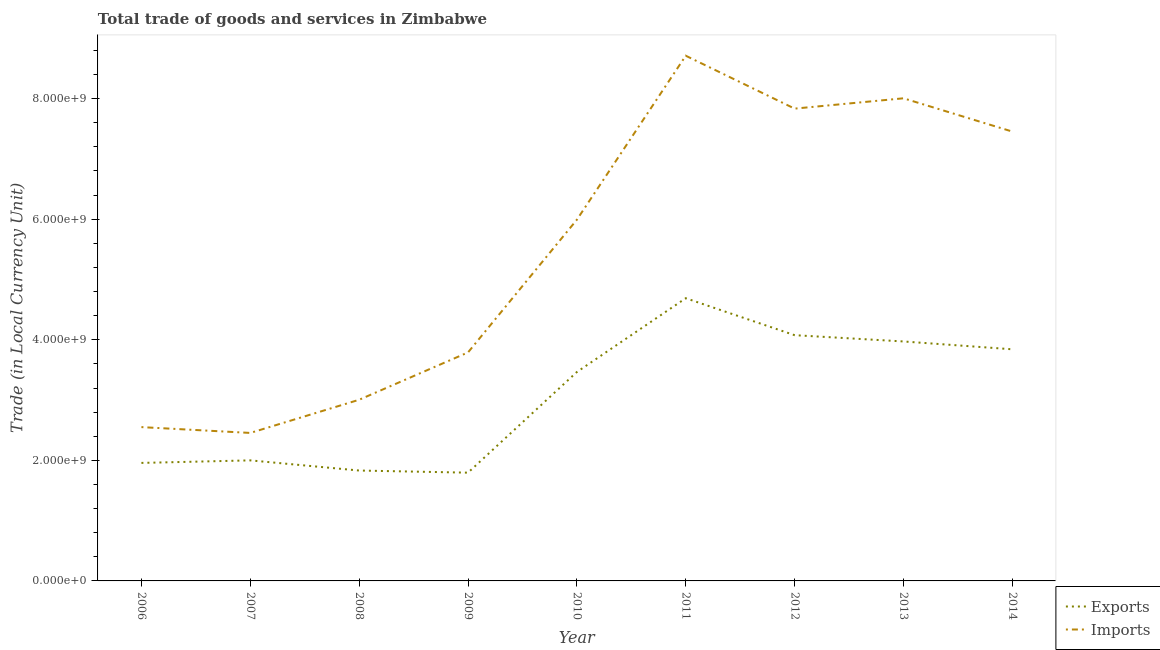Is the number of lines equal to the number of legend labels?
Offer a very short reply. Yes. What is the imports of goods and services in 2008?
Provide a short and direct response. 3.01e+09. Across all years, what is the maximum imports of goods and services?
Your response must be concise. 8.71e+09. Across all years, what is the minimum imports of goods and services?
Keep it short and to the point. 2.45e+09. What is the total imports of goods and services in the graph?
Ensure brevity in your answer.  4.98e+1. What is the difference between the export of goods and services in 2010 and that in 2013?
Your answer should be compact. -5.06e+08. What is the difference between the export of goods and services in 2006 and the imports of goods and services in 2010?
Offer a terse response. -4.03e+09. What is the average export of goods and services per year?
Provide a short and direct response. 3.07e+09. In the year 2014, what is the difference between the imports of goods and services and export of goods and services?
Your answer should be compact. 3.61e+09. In how many years, is the export of goods and services greater than 400000000 LCU?
Provide a succinct answer. 9. What is the ratio of the export of goods and services in 2009 to that in 2010?
Give a very brief answer. 0.52. Is the imports of goods and services in 2012 less than that in 2014?
Make the answer very short. No. What is the difference between the highest and the second highest export of goods and services?
Your answer should be very brief. 6.13e+08. What is the difference between the highest and the lowest imports of goods and services?
Make the answer very short. 6.26e+09. In how many years, is the imports of goods and services greater than the average imports of goods and services taken over all years?
Give a very brief answer. 5. Is the sum of the imports of goods and services in 2008 and 2009 greater than the maximum export of goods and services across all years?
Your answer should be very brief. Yes. Does the export of goods and services monotonically increase over the years?
Offer a very short reply. No. Is the export of goods and services strictly less than the imports of goods and services over the years?
Offer a terse response. Yes. How many lines are there?
Keep it short and to the point. 2. How many years are there in the graph?
Make the answer very short. 9. What is the difference between two consecutive major ticks on the Y-axis?
Your answer should be compact. 2.00e+09. Are the values on the major ticks of Y-axis written in scientific E-notation?
Offer a terse response. Yes. Where does the legend appear in the graph?
Make the answer very short. Bottom right. How are the legend labels stacked?
Your response must be concise. Vertical. What is the title of the graph?
Make the answer very short. Total trade of goods and services in Zimbabwe. What is the label or title of the Y-axis?
Provide a short and direct response. Trade (in Local Currency Unit). What is the Trade (in Local Currency Unit) of Exports in 2006?
Make the answer very short. 1.96e+09. What is the Trade (in Local Currency Unit) in Imports in 2006?
Offer a terse response. 2.55e+09. What is the Trade (in Local Currency Unit) of Exports in 2007?
Make the answer very short. 2.00e+09. What is the Trade (in Local Currency Unit) in Imports in 2007?
Your answer should be compact. 2.45e+09. What is the Trade (in Local Currency Unit) of Exports in 2008?
Your answer should be very brief. 1.83e+09. What is the Trade (in Local Currency Unit) in Imports in 2008?
Give a very brief answer. 3.01e+09. What is the Trade (in Local Currency Unit) in Exports in 2009?
Give a very brief answer. 1.80e+09. What is the Trade (in Local Currency Unit) of Imports in 2009?
Offer a very short reply. 3.79e+09. What is the Trade (in Local Currency Unit) in Exports in 2010?
Offer a very short reply. 3.47e+09. What is the Trade (in Local Currency Unit) in Imports in 2010?
Keep it short and to the point. 5.99e+09. What is the Trade (in Local Currency Unit) of Exports in 2011?
Your response must be concise. 4.69e+09. What is the Trade (in Local Currency Unit) of Imports in 2011?
Make the answer very short. 8.71e+09. What is the Trade (in Local Currency Unit) in Exports in 2012?
Your answer should be very brief. 4.08e+09. What is the Trade (in Local Currency Unit) in Imports in 2012?
Your answer should be compact. 7.83e+09. What is the Trade (in Local Currency Unit) in Exports in 2013?
Give a very brief answer. 3.97e+09. What is the Trade (in Local Currency Unit) of Imports in 2013?
Your answer should be compact. 8.01e+09. What is the Trade (in Local Currency Unit) of Exports in 2014?
Keep it short and to the point. 3.84e+09. What is the Trade (in Local Currency Unit) in Imports in 2014?
Keep it short and to the point. 7.45e+09. Across all years, what is the maximum Trade (in Local Currency Unit) of Exports?
Provide a succinct answer. 4.69e+09. Across all years, what is the maximum Trade (in Local Currency Unit) of Imports?
Make the answer very short. 8.71e+09. Across all years, what is the minimum Trade (in Local Currency Unit) of Exports?
Give a very brief answer. 1.80e+09. Across all years, what is the minimum Trade (in Local Currency Unit) of Imports?
Make the answer very short. 2.45e+09. What is the total Trade (in Local Currency Unit) in Exports in the graph?
Keep it short and to the point. 2.76e+1. What is the total Trade (in Local Currency Unit) of Imports in the graph?
Provide a short and direct response. 4.98e+1. What is the difference between the Trade (in Local Currency Unit) in Exports in 2006 and that in 2007?
Your response must be concise. -4.22e+07. What is the difference between the Trade (in Local Currency Unit) of Imports in 2006 and that in 2007?
Ensure brevity in your answer.  9.64e+07. What is the difference between the Trade (in Local Currency Unit) in Exports in 2006 and that in 2008?
Offer a terse response. 1.26e+08. What is the difference between the Trade (in Local Currency Unit) of Imports in 2006 and that in 2008?
Your response must be concise. -4.54e+08. What is the difference between the Trade (in Local Currency Unit) in Exports in 2006 and that in 2009?
Provide a succinct answer. 1.62e+08. What is the difference between the Trade (in Local Currency Unit) of Imports in 2006 and that in 2009?
Provide a succinct answer. -1.24e+09. What is the difference between the Trade (in Local Currency Unit) in Exports in 2006 and that in 2010?
Offer a terse response. -1.51e+09. What is the difference between the Trade (in Local Currency Unit) in Imports in 2006 and that in 2010?
Provide a short and direct response. -3.44e+09. What is the difference between the Trade (in Local Currency Unit) in Exports in 2006 and that in 2011?
Provide a succinct answer. -2.73e+09. What is the difference between the Trade (in Local Currency Unit) in Imports in 2006 and that in 2011?
Ensure brevity in your answer.  -6.16e+09. What is the difference between the Trade (in Local Currency Unit) in Exports in 2006 and that in 2012?
Give a very brief answer. -2.12e+09. What is the difference between the Trade (in Local Currency Unit) in Imports in 2006 and that in 2012?
Provide a short and direct response. -5.28e+09. What is the difference between the Trade (in Local Currency Unit) in Exports in 2006 and that in 2013?
Keep it short and to the point. -2.01e+09. What is the difference between the Trade (in Local Currency Unit) of Imports in 2006 and that in 2013?
Your response must be concise. -5.45e+09. What is the difference between the Trade (in Local Currency Unit) of Exports in 2006 and that in 2014?
Keep it short and to the point. -1.88e+09. What is the difference between the Trade (in Local Currency Unit) in Imports in 2006 and that in 2014?
Offer a terse response. -4.90e+09. What is the difference between the Trade (in Local Currency Unit) of Exports in 2007 and that in 2008?
Provide a short and direct response. 1.69e+08. What is the difference between the Trade (in Local Currency Unit) of Imports in 2007 and that in 2008?
Make the answer very short. -5.50e+08. What is the difference between the Trade (in Local Currency Unit) in Exports in 2007 and that in 2009?
Make the answer very short. 2.04e+08. What is the difference between the Trade (in Local Currency Unit) in Imports in 2007 and that in 2009?
Your answer should be compact. -1.34e+09. What is the difference between the Trade (in Local Currency Unit) of Exports in 2007 and that in 2010?
Offer a very short reply. -1.47e+09. What is the difference between the Trade (in Local Currency Unit) in Imports in 2007 and that in 2010?
Your response must be concise. -3.54e+09. What is the difference between the Trade (in Local Currency Unit) of Exports in 2007 and that in 2011?
Provide a succinct answer. -2.69e+09. What is the difference between the Trade (in Local Currency Unit) of Imports in 2007 and that in 2011?
Give a very brief answer. -6.26e+09. What is the difference between the Trade (in Local Currency Unit) in Exports in 2007 and that in 2012?
Your response must be concise. -2.08e+09. What is the difference between the Trade (in Local Currency Unit) of Imports in 2007 and that in 2012?
Offer a very short reply. -5.38e+09. What is the difference between the Trade (in Local Currency Unit) in Exports in 2007 and that in 2013?
Your answer should be compact. -1.97e+09. What is the difference between the Trade (in Local Currency Unit) in Imports in 2007 and that in 2013?
Keep it short and to the point. -5.55e+09. What is the difference between the Trade (in Local Currency Unit) in Exports in 2007 and that in 2014?
Your answer should be compact. -1.84e+09. What is the difference between the Trade (in Local Currency Unit) in Imports in 2007 and that in 2014?
Ensure brevity in your answer.  -5.00e+09. What is the difference between the Trade (in Local Currency Unit) in Exports in 2008 and that in 2009?
Your answer should be very brief. 3.54e+07. What is the difference between the Trade (in Local Currency Unit) in Imports in 2008 and that in 2009?
Your answer should be compact. -7.85e+08. What is the difference between the Trade (in Local Currency Unit) of Exports in 2008 and that in 2010?
Offer a very short reply. -1.63e+09. What is the difference between the Trade (in Local Currency Unit) of Imports in 2008 and that in 2010?
Offer a very short reply. -2.99e+09. What is the difference between the Trade (in Local Currency Unit) in Exports in 2008 and that in 2011?
Offer a very short reply. -2.86e+09. What is the difference between the Trade (in Local Currency Unit) of Imports in 2008 and that in 2011?
Make the answer very short. -5.71e+09. What is the difference between the Trade (in Local Currency Unit) of Exports in 2008 and that in 2012?
Give a very brief answer. -2.25e+09. What is the difference between the Trade (in Local Currency Unit) of Imports in 2008 and that in 2012?
Give a very brief answer. -4.83e+09. What is the difference between the Trade (in Local Currency Unit) in Exports in 2008 and that in 2013?
Keep it short and to the point. -2.14e+09. What is the difference between the Trade (in Local Currency Unit) in Imports in 2008 and that in 2013?
Make the answer very short. -5.00e+09. What is the difference between the Trade (in Local Currency Unit) of Exports in 2008 and that in 2014?
Provide a succinct answer. -2.01e+09. What is the difference between the Trade (in Local Currency Unit) in Imports in 2008 and that in 2014?
Offer a terse response. -4.45e+09. What is the difference between the Trade (in Local Currency Unit) of Exports in 2009 and that in 2010?
Make the answer very short. -1.67e+09. What is the difference between the Trade (in Local Currency Unit) in Imports in 2009 and that in 2010?
Your response must be concise. -2.20e+09. What is the difference between the Trade (in Local Currency Unit) in Exports in 2009 and that in 2011?
Make the answer very short. -2.89e+09. What is the difference between the Trade (in Local Currency Unit) in Imports in 2009 and that in 2011?
Offer a very short reply. -4.92e+09. What is the difference between the Trade (in Local Currency Unit) of Exports in 2009 and that in 2012?
Your answer should be very brief. -2.28e+09. What is the difference between the Trade (in Local Currency Unit) of Imports in 2009 and that in 2012?
Your answer should be compact. -4.04e+09. What is the difference between the Trade (in Local Currency Unit) in Exports in 2009 and that in 2013?
Offer a terse response. -2.18e+09. What is the difference between the Trade (in Local Currency Unit) of Imports in 2009 and that in 2013?
Ensure brevity in your answer.  -4.22e+09. What is the difference between the Trade (in Local Currency Unit) of Exports in 2009 and that in 2014?
Offer a very short reply. -2.05e+09. What is the difference between the Trade (in Local Currency Unit) of Imports in 2009 and that in 2014?
Give a very brief answer. -3.66e+09. What is the difference between the Trade (in Local Currency Unit) in Exports in 2010 and that in 2011?
Your answer should be compact. -1.22e+09. What is the difference between the Trade (in Local Currency Unit) of Imports in 2010 and that in 2011?
Provide a succinct answer. -2.72e+09. What is the difference between the Trade (in Local Currency Unit) in Exports in 2010 and that in 2012?
Your response must be concise. -6.11e+08. What is the difference between the Trade (in Local Currency Unit) of Imports in 2010 and that in 2012?
Your response must be concise. -1.84e+09. What is the difference between the Trade (in Local Currency Unit) of Exports in 2010 and that in 2013?
Your response must be concise. -5.06e+08. What is the difference between the Trade (in Local Currency Unit) of Imports in 2010 and that in 2013?
Make the answer very short. -2.01e+09. What is the difference between the Trade (in Local Currency Unit) of Exports in 2010 and that in 2014?
Make the answer very short. -3.76e+08. What is the difference between the Trade (in Local Currency Unit) in Imports in 2010 and that in 2014?
Offer a very short reply. -1.46e+09. What is the difference between the Trade (in Local Currency Unit) in Exports in 2011 and that in 2012?
Your answer should be very brief. 6.13e+08. What is the difference between the Trade (in Local Currency Unit) in Imports in 2011 and that in 2012?
Your answer should be very brief. 8.77e+08. What is the difference between the Trade (in Local Currency Unit) of Exports in 2011 and that in 2013?
Provide a short and direct response. 7.17e+08. What is the difference between the Trade (in Local Currency Unit) in Imports in 2011 and that in 2013?
Your answer should be very brief. 7.06e+08. What is the difference between the Trade (in Local Currency Unit) in Exports in 2011 and that in 2014?
Your response must be concise. 8.47e+08. What is the difference between the Trade (in Local Currency Unit) of Imports in 2011 and that in 2014?
Your response must be concise. 1.26e+09. What is the difference between the Trade (in Local Currency Unit) of Exports in 2012 and that in 2013?
Your answer should be very brief. 1.04e+08. What is the difference between the Trade (in Local Currency Unit) in Imports in 2012 and that in 2013?
Give a very brief answer. -1.71e+08. What is the difference between the Trade (in Local Currency Unit) of Exports in 2012 and that in 2014?
Offer a terse response. 2.34e+08. What is the difference between the Trade (in Local Currency Unit) of Imports in 2012 and that in 2014?
Provide a short and direct response. 3.81e+08. What is the difference between the Trade (in Local Currency Unit) in Exports in 2013 and that in 2014?
Make the answer very short. 1.30e+08. What is the difference between the Trade (in Local Currency Unit) of Imports in 2013 and that in 2014?
Keep it short and to the point. 5.52e+08. What is the difference between the Trade (in Local Currency Unit) of Exports in 2006 and the Trade (in Local Currency Unit) of Imports in 2007?
Ensure brevity in your answer.  -4.97e+08. What is the difference between the Trade (in Local Currency Unit) in Exports in 2006 and the Trade (in Local Currency Unit) in Imports in 2008?
Your answer should be very brief. -1.05e+09. What is the difference between the Trade (in Local Currency Unit) in Exports in 2006 and the Trade (in Local Currency Unit) in Imports in 2009?
Your answer should be very brief. -1.83e+09. What is the difference between the Trade (in Local Currency Unit) of Exports in 2006 and the Trade (in Local Currency Unit) of Imports in 2010?
Offer a very short reply. -4.03e+09. What is the difference between the Trade (in Local Currency Unit) of Exports in 2006 and the Trade (in Local Currency Unit) of Imports in 2011?
Keep it short and to the point. -6.75e+09. What is the difference between the Trade (in Local Currency Unit) of Exports in 2006 and the Trade (in Local Currency Unit) of Imports in 2012?
Keep it short and to the point. -5.88e+09. What is the difference between the Trade (in Local Currency Unit) in Exports in 2006 and the Trade (in Local Currency Unit) in Imports in 2013?
Offer a terse response. -6.05e+09. What is the difference between the Trade (in Local Currency Unit) in Exports in 2006 and the Trade (in Local Currency Unit) in Imports in 2014?
Provide a short and direct response. -5.50e+09. What is the difference between the Trade (in Local Currency Unit) in Exports in 2007 and the Trade (in Local Currency Unit) in Imports in 2008?
Your answer should be compact. -1.01e+09. What is the difference between the Trade (in Local Currency Unit) in Exports in 2007 and the Trade (in Local Currency Unit) in Imports in 2009?
Give a very brief answer. -1.79e+09. What is the difference between the Trade (in Local Currency Unit) in Exports in 2007 and the Trade (in Local Currency Unit) in Imports in 2010?
Give a very brief answer. -3.99e+09. What is the difference between the Trade (in Local Currency Unit) in Exports in 2007 and the Trade (in Local Currency Unit) in Imports in 2011?
Your answer should be compact. -6.71e+09. What is the difference between the Trade (in Local Currency Unit) of Exports in 2007 and the Trade (in Local Currency Unit) of Imports in 2012?
Provide a short and direct response. -5.83e+09. What is the difference between the Trade (in Local Currency Unit) in Exports in 2007 and the Trade (in Local Currency Unit) in Imports in 2013?
Offer a very short reply. -6.01e+09. What is the difference between the Trade (in Local Currency Unit) in Exports in 2007 and the Trade (in Local Currency Unit) in Imports in 2014?
Give a very brief answer. -5.45e+09. What is the difference between the Trade (in Local Currency Unit) of Exports in 2008 and the Trade (in Local Currency Unit) of Imports in 2009?
Provide a succinct answer. -1.96e+09. What is the difference between the Trade (in Local Currency Unit) in Exports in 2008 and the Trade (in Local Currency Unit) in Imports in 2010?
Provide a short and direct response. -4.16e+09. What is the difference between the Trade (in Local Currency Unit) in Exports in 2008 and the Trade (in Local Currency Unit) in Imports in 2011?
Your response must be concise. -6.88e+09. What is the difference between the Trade (in Local Currency Unit) of Exports in 2008 and the Trade (in Local Currency Unit) of Imports in 2012?
Your answer should be very brief. -6.00e+09. What is the difference between the Trade (in Local Currency Unit) of Exports in 2008 and the Trade (in Local Currency Unit) of Imports in 2013?
Your answer should be very brief. -6.17e+09. What is the difference between the Trade (in Local Currency Unit) in Exports in 2008 and the Trade (in Local Currency Unit) in Imports in 2014?
Your answer should be very brief. -5.62e+09. What is the difference between the Trade (in Local Currency Unit) in Exports in 2009 and the Trade (in Local Currency Unit) in Imports in 2010?
Provide a short and direct response. -4.20e+09. What is the difference between the Trade (in Local Currency Unit) in Exports in 2009 and the Trade (in Local Currency Unit) in Imports in 2011?
Your response must be concise. -6.92e+09. What is the difference between the Trade (in Local Currency Unit) of Exports in 2009 and the Trade (in Local Currency Unit) of Imports in 2012?
Your answer should be compact. -6.04e+09. What is the difference between the Trade (in Local Currency Unit) in Exports in 2009 and the Trade (in Local Currency Unit) in Imports in 2013?
Your response must be concise. -6.21e+09. What is the difference between the Trade (in Local Currency Unit) in Exports in 2009 and the Trade (in Local Currency Unit) in Imports in 2014?
Provide a short and direct response. -5.66e+09. What is the difference between the Trade (in Local Currency Unit) in Exports in 2010 and the Trade (in Local Currency Unit) in Imports in 2011?
Your answer should be compact. -5.25e+09. What is the difference between the Trade (in Local Currency Unit) in Exports in 2010 and the Trade (in Local Currency Unit) in Imports in 2012?
Provide a short and direct response. -4.37e+09. What is the difference between the Trade (in Local Currency Unit) of Exports in 2010 and the Trade (in Local Currency Unit) of Imports in 2013?
Your response must be concise. -4.54e+09. What is the difference between the Trade (in Local Currency Unit) in Exports in 2010 and the Trade (in Local Currency Unit) in Imports in 2014?
Offer a terse response. -3.99e+09. What is the difference between the Trade (in Local Currency Unit) of Exports in 2011 and the Trade (in Local Currency Unit) of Imports in 2012?
Offer a very short reply. -3.14e+09. What is the difference between the Trade (in Local Currency Unit) in Exports in 2011 and the Trade (in Local Currency Unit) in Imports in 2013?
Your response must be concise. -3.32e+09. What is the difference between the Trade (in Local Currency Unit) in Exports in 2011 and the Trade (in Local Currency Unit) in Imports in 2014?
Make the answer very short. -2.76e+09. What is the difference between the Trade (in Local Currency Unit) in Exports in 2012 and the Trade (in Local Currency Unit) in Imports in 2013?
Offer a very short reply. -3.93e+09. What is the difference between the Trade (in Local Currency Unit) in Exports in 2012 and the Trade (in Local Currency Unit) in Imports in 2014?
Keep it short and to the point. -3.38e+09. What is the difference between the Trade (in Local Currency Unit) of Exports in 2013 and the Trade (in Local Currency Unit) of Imports in 2014?
Keep it short and to the point. -3.48e+09. What is the average Trade (in Local Currency Unit) of Exports per year?
Offer a very short reply. 3.07e+09. What is the average Trade (in Local Currency Unit) of Imports per year?
Your response must be concise. 5.53e+09. In the year 2006, what is the difference between the Trade (in Local Currency Unit) of Exports and Trade (in Local Currency Unit) of Imports?
Offer a very short reply. -5.94e+08. In the year 2007, what is the difference between the Trade (in Local Currency Unit) of Exports and Trade (in Local Currency Unit) of Imports?
Your answer should be very brief. -4.55e+08. In the year 2008, what is the difference between the Trade (in Local Currency Unit) in Exports and Trade (in Local Currency Unit) in Imports?
Provide a succinct answer. -1.17e+09. In the year 2009, what is the difference between the Trade (in Local Currency Unit) of Exports and Trade (in Local Currency Unit) of Imports?
Provide a succinct answer. -1.99e+09. In the year 2010, what is the difference between the Trade (in Local Currency Unit) in Exports and Trade (in Local Currency Unit) in Imports?
Your answer should be compact. -2.53e+09. In the year 2011, what is the difference between the Trade (in Local Currency Unit) of Exports and Trade (in Local Currency Unit) of Imports?
Make the answer very short. -4.02e+09. In the year 2012, what is the difference between the Trade (in Local Currency Unit) in Exports and Trade (in Local Currency Unit) in Imports?
Offer a terse response. -3.76e+09. In the year 2013, what is the difference between the Trade (in Local Currency Unit) in Exports and Trade (in Local Currency Unit) in Imports?
Ensure brevity in your answer.  -4.03e+09. In the year 2014, what is the difference between the Trade (in Local Currency Unit) of Exports and Trade (in Local Currency Unit) of Imports?
Your answer should be very brief. -3.61e+09. What is the ratio of the Trade (in Local Currency Unit) in Exports in 2006 to that in 2007?
Offer a very short reply. 0.98. What is the ratio of the Trade (in Local Currency Unit) of Imports in 2006 to that in 2007?
Provide a succinct answer. 1.04. What is the ratio of the Trade (in Local Currency Unit) in Exports in 2006 to that in 2008?
Offer a terse response. 1.07. What is the ratio of the Trade (in Local Currency Unit) in Imports in 2006 to that in 2008?
Ensure brevity in your answer.  0.85. What is the ratio of the Trade (in Local Currency Unit) in Exports in 2006 to that in 2009?
Your answer should be compact. 1.09. What is the ratio of the Trade (in Local Currency Unit) of Imports in 2006 to that in 2009?
Your response must be concise. 0.67. What is the ratio of the Trade (in Local Currency Unit) of Exports in 2006 to that in 2010?
Provide a short and direct response. 0.56. What is the ratio of the Trade (in Local Currency Unit) of Imports in 2006 to that in 2010?
Keep it short and to the point. 0.43. What is the ratio of the Trade (in Local Currency Unit) of Exports in 2006 to that in 2011?
Offer a terse response. 0.42. What is the ratio of the Trade (in Local Currency Unit) of Imports in 2006 to that in 2011?
Provide a short and direct response. 0.29. What is the ratio of the Trade (in Local Currency Unit) in Exports in 2006 to that in 2012?
Your answer should be compact. 0.48. What is the ratio of the Trade (in Local Currency Unit) in Imports in 2006 to that in 2012?
Give a very brief answer. 0.33. What is the ratio of the Trade (in Local Currency Unit) of Exports in 2006 to that in 2013?
Offer a terse response. 0.49. What is the ratio of the Trade (in Local Currency Unit) of Imports in 2006 to that in 2013?
Your answer should be compact. 0.32. What is the ratio of the Trade (in Local Currency Unit) of Exports in 2006 to that in 2014?
Provide a short and direct response. 0.51. What is the ratio of the Trade (in Local Currency Unit) of Imports in 2006 to that in 2014?
Your answer should be very brief. 0.34. What is the ratio of the Trade (in Local Currency Unit) of Exports in 2007 to that in 2008?
Offer a very short reply. 1.09. What is the ratio of the Trade (in Local Currency Unit) in Imports in 2007 to that in 2008?
Ensure brevity in your answer.  0.82. What is the ratio of the Trade (in Local Currency Unit) of Exports in 2007 to that in 2009?
Your answer should be very brief. 1.11. What is the ratio of the Trade (in Local Currency Unit) in Imports in 2007 to that in 2009?
Keep it short and to the point. 0.65. What is the ratio of the Trade (in Local Currency Unit) of Exports in 2007 to that in 2010?
Give a very brief answer. 0.58. What is the ratio of the Trade (in Local Currency Unit) in Imports in 2007 to that in 2010?
Your response must be concise. 0.41. What is the ratio of the Trade (in Local Currency Unit) in Exports in 2007 to that in 2011?
Provide a succinct answer. 0.43. What is the ratio of the Trade (in Local Currency Unit) of Imports in 2007 to that in 2011?
Give a very brief answer. 0.28. What is the ratio of the Trade (in Local Currency Unit) in Exports in 2007 to that in 2012?
Your answer should be very brief. 0.49. What is the ratio of the Trade (in Local Currency Unit) of Imports in 2007 to that in 2012?
Offer a very short reply. 0.31. What is the ratio of the Trade (in Local Currency Unit) in Exports in 2007 to that in 2013?
Your answer should be very brief. 0.5. What is the ratio of the Trade (in Local Currency Unit) in Imports in 2007 to that in 2013?
Provide a succinct answer. 0.31. What is the ratio of the Trade (in Local Currency Unit) of Exports in 2007 to that in 2014?
Your answer should be very brief. 0.52. What is the ratio of the Trade (in Local Currency Unit) in Imports in 2007 to that in 2014?
Make the answer very short. 0.33. What is the ratio of the Trade (in Local Currency Unit) of Exports in 2008 to that in 2009?
Give a very brief answer. 1.02. What is the ratio of the Trade (in Local Currency Unit) in Imports in 2008 to that in 2009?
Keep it short and to the point. 0.79. What is the ratio of the Trade (in Local Currency Unit) of Exports in 2008 to that in 2010?
Offer a terse response. 0.53. What is the ratio of the Trade (in Local Currency Unit) of Imports in 2008 to that in 2010?
Offer a terse response. 0.5. What is the ratio of the Trade (in Local Currency Unit) in Exports in 2008 to that in 2011?
Ensure brevity in your answer.  0.39. What is the ratio of the Trade (in Local Currency Unit) in Imports in 2008 to that in 2011?
Provide a succinct answer. 0.34. What is the ratio of the Trade (in Local Currency Unit) of Exports in 2008 to that in 2012?
Provide a succinct answer. 0.45. What is the ratio of the Trade (in Local Currency Unit) in Imports in 2008 to that in 2012?
Your answer should be compact. 0.38. What is the ratio of the Trade (in Local Currency Unit) in Exports in 2008 to that in 2013?
Make the answer very short. 0.46. What is the ratio of the Trade (in Local Currency Unit) in Imports in 2008 to that in 2013?
Provide a succinct answer. 0.38. What is the ratio of the Trade (in Local Currency Unit) in Exports in 2008 to that in 2014?
Your response must be concise. 0.48. What is the ratio of the Trade (in Local Currency Unit) in Imports in 2008 to that in 2014?
Your answer should be compact. 0.4. What is the ratio of the Trade (in Local Currency Unit) of Exports in 2009 to that in 2010?
Offer a terse response. 0.52. What is the ratio of the Trade (in Local Currency Unit) in Imports in 2009 to that in 2010?
Offer a terse response. 0.63. What is the ratio of the Trade (in Local Currency Unit) of Exports in 2009 to that in 2011?
Provide a short and direct response. 0.38. What is the ratio of the Trade (in Local Currency Unit) in Imports in 2009 to that in 2011?
Keep it short and to the point. 0.44. What is the ratio of the Trade (in Local Currency Unit) in Exports in 2009 to that in 2012?
Your answer should be very brief. 0.44. What is the ratio of the Trade (in Local Currency Unit) in Imports in 2009 to that in 2012?
Your response must be concise. 0.48. What is the ratio of the Trade (in Local Currency Unit) in Exports in 2009 to that in 2013?
Your answer should be very brief. 0.45. What is the ratio of the Trade (in Local Currency Unit) of Imports in 2009 to that in 2013?
Your answer should be compact. 0.47. What is the ratio of the Trade (in Local Currency Unit) of Exports in 2009 to that in 2014?
Offer a terse response. 0.47. What is the ratio of the Trade (in Local Currency Unit) of Imports in 2009 to that in 2014?
Your answer should be very brief. 0.51. What is the ratio of the Trade (in Local Currency Unit) of Exports in 2010 to that in 2011?
Your answer should be compact. 0.74. What is the ratio of the Trade (in Local Currency Unit) in Imports in 2010 to that in 2011?
Your response must be concise. 0.69. What is the ratio of the Trade (in Local Currency Unit) in Exports in 2010 to that in 2012?
Offer a terse response. 0.85. What is the ratio of the Trade (in Local Currency Unit) of Imports in 2010 to that in 2012?
Your answer should be compact. 0.76. What is the ratio of the Trade (in Local Currency Unit) of Exports in 2010 to that in 2013?
Your response must be concise. 0.87. What is the ratio of the Trade (in Local Currency Unit) of Imports in 2010 to that in 2013?
Keep it short and to the point. 0.75. What is the ratio of the Trade (in Local Currency Unit) in Exports in 2010 to that in 2014?
Make the answer very short. 0.9. What is the ratio of the Trade (in Local Currency Unit) of Imports in 2010 to that in 2014?
Your response must be concise. 0.8. What is the ratio of the Trade (in Local Currency Unit) of Exports in 2011 to that in 2012?
Provide a succinct answer. 1.15. What is the ratio of the Trade (in Local Currency Unit) of Imports in 2011 to that in 2012?
Offer a very short reply. 1.11. What is the ratio of the Trade (in Local Currency Unit) in Exports in 2011 to that in 2013?
Ensure brevity in your answer.  1.18. What is the ratio of the Trade (in Local Currency Unit) in Imports in 2011 to that in 2013?
Offer a very short reply. 1.09. What is the ratio of the Trade (in Local Currency Unit) in Exports in 2011 to that in 2014?
Provide a succinct answer. 1.22. What is the ratio of the Trade (in Local Currency Unit) of Imports in 2011 to that in 2014?
Give a very brief answer. 1.17. What is the ratio of the Trade (in Local Currency Unit) of Exports in 2012 to that in 2013?
Your answer should be compact. 1.03. What is the ratio of the Trade (in Local Currency Unit) in Imports in 2012 to that in 2013?
Keep it short and to the point. 0.98. What is the ratio of the Trade (in Local Currency Unit) in Exports in 2012 to that in 2014?
Make the answer very short. 1.06. What is the ratio of the Trade (in Local Currency Unit) in Imports in 2012 to that in 2014?
Provide a short and direct response. 1.05. What is the ratio of the Trade (in Local Currency Unit) in Exports in 2013 to that in 2014?
Your answer should be compact. 1.03. What is the ratio of the Trade (in Local Currency Unit) of Imports in 2013 to that in 2014?
Your answer should be compact. 1.07. What is the difference between the highest and the second highest Trade (in Local Currency Unit) in Exports?
Your response must be concise. 6.13e+08. What is the difference between the highest and the second highest Trade (in Local Currency Unit) in Imports?
Make the answer very short. 7.06e+08. What is the difference between the highest and the lowest Trade (in Local Currency Unit) in Exports?
Offer a terse response. 2.89e+09. What is the difference between the highest and the lowest Trade (in Local Currency Unit) of Imports?
Ensure brevity in your answer.  6.26e+09. 